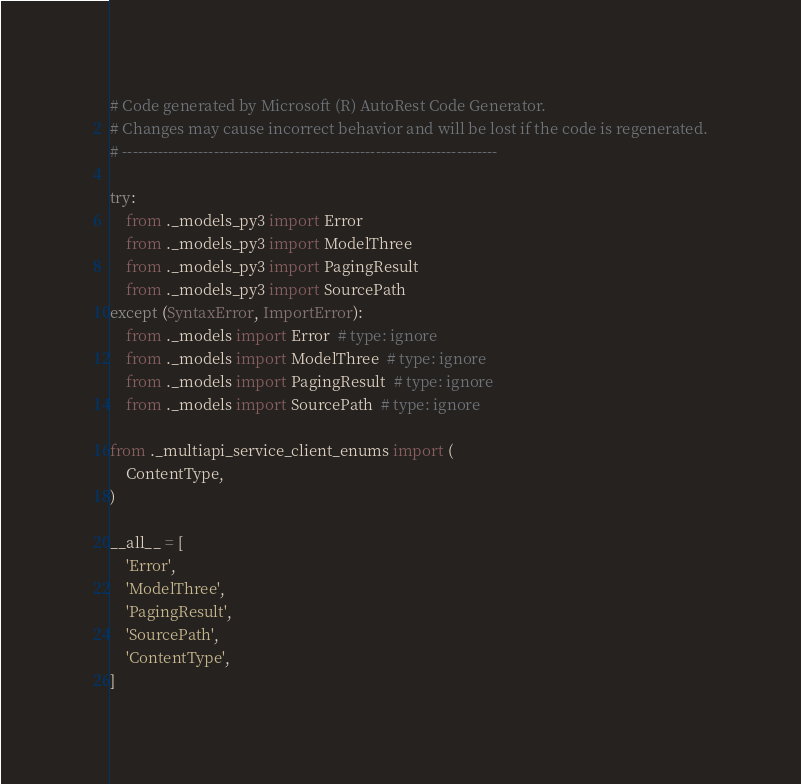Convert code to text. <code><loc_0><loc_0><loc_500><loc_500><_Python_># Code generated by Microsoft (R) AutoRest Code Generator.
# Changes may cause incorrect behavior and will be lost if the code is regenerated.
# --------------------------------------------------------------------------

try:
    from ._models_py3 import Error
    from ._models_py3 import ModelThree
    from ._models_py3 import PagingResult
    from ._models_py3 import SourcePath
except (SyntaxError, ImportError):
    from ._models import Error  # type: ignore
    from ._models import ModelThree  # type: ignore
    from ._models import PagingResult  # type: ignore
    from ._models import SourcePath  # type: ignore

from ._multiapi_service_client_enums import (
    ContentType,
)

__all__ = [
    'Error',
    'ModelThree',
    'PagingResult',
    'SourcePath',
    'ContentType',
]
</code> 